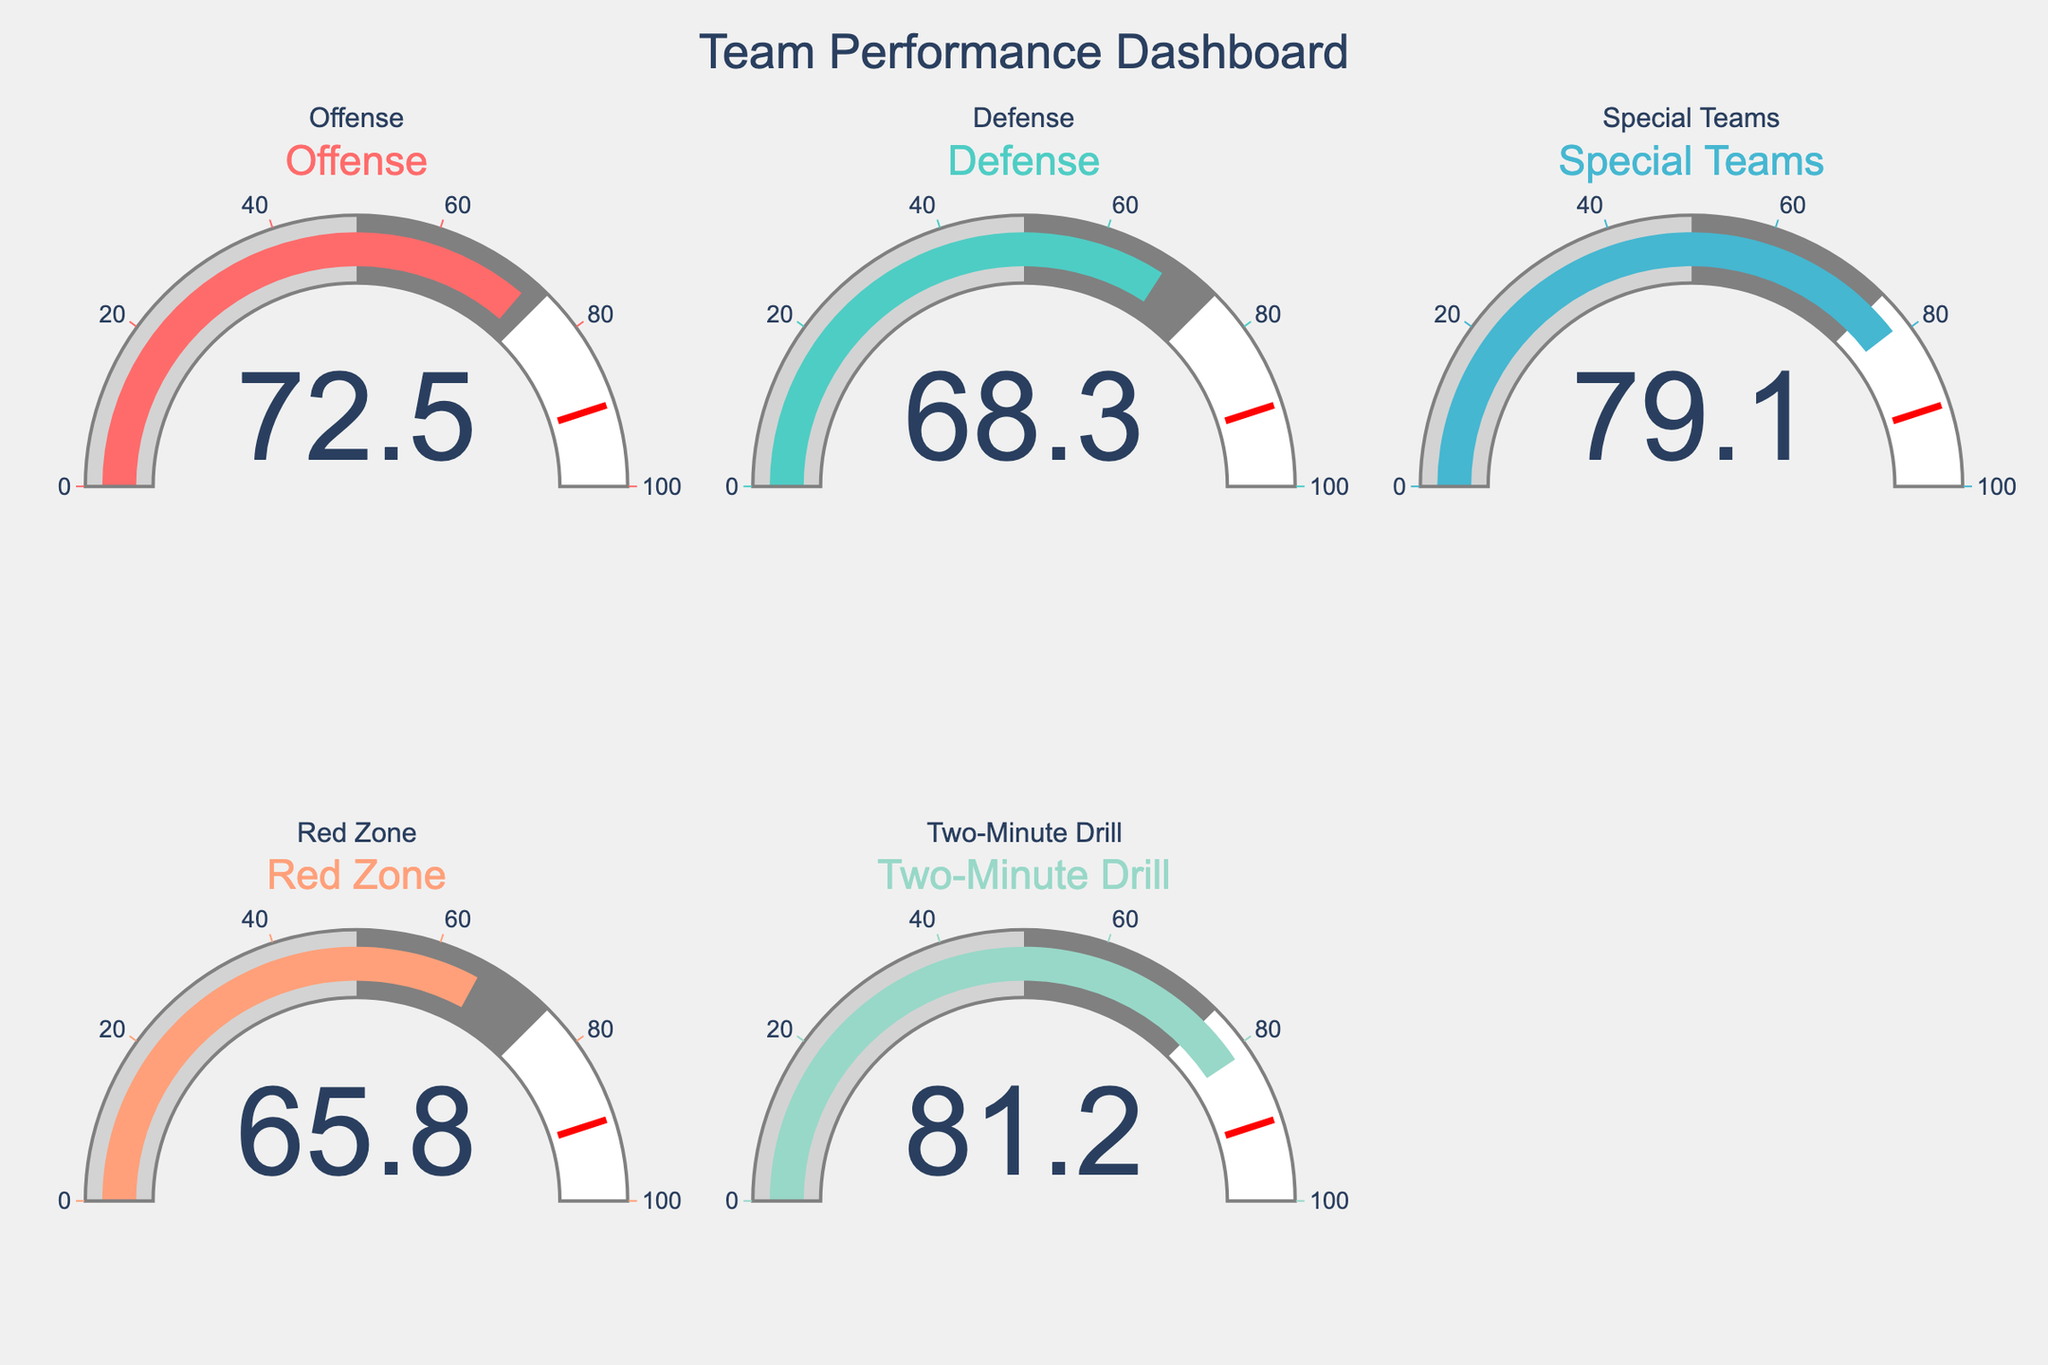What is the title of the plot? The title of the plot can be found at the top of the figure. It provides an overview of what the plot represents.
Answer: Team Performance Dashboard Which team has the highest percentage of successful plays? By looking at the value displayed on each gauge, we identify the team with the highest number.
Answer: Two-Minute Drill What is the percentage of successful plays for the Defense team? Locate the gauge labeled "Defense" and read the percentage value displayed.
Answer: 68.3% How many teams have a successful play percentage above 70%? Check each gauge and count the number of gauges showing a value above 70.
Answer: 3 What is the difference in successful play percentage between Offense and Red Zone teams? Subtract the percentage of the Red Zone team from the percentage of the Offense team. 72.5% - 65.8% = 6.7%
Answer: 6.7% How does the Offense team's success compare to the Defense team's? Compare the percentage values displayed on the gauges for the Offense and Defense teams. The Offense has a higher value than the Defense.
Answer: Offense: 72.5%, Defense: 68.3% Calculate the average success percentage across all the teams. Sum all the percentages and divide by the number of teams: (72.5 + 68.3 + 79.1 + 65.8 + 81.2) / 5 = 73.38%
Answer: 73.38% Which team's performance is closest to the average success percentage? First calculate the average percentage, and then identify the team whose percentage is nearest to this average. Average is 73.38%, and Offense at 72.5% is the closest.
Answer: Offense What is the median percentage of successful plays across all teams? Order the percentages and find the middle value. The ordered values are 65.8, 68.3, 72.5, 79.1, and 81.2. The median is the third value: 72.5%.
Answer: 72.5% Are there any teams that have a successful play percentage below 70%? Check each gauge to see if any are displaying a percentage below 70.
Answer: Red Zone and Defense 